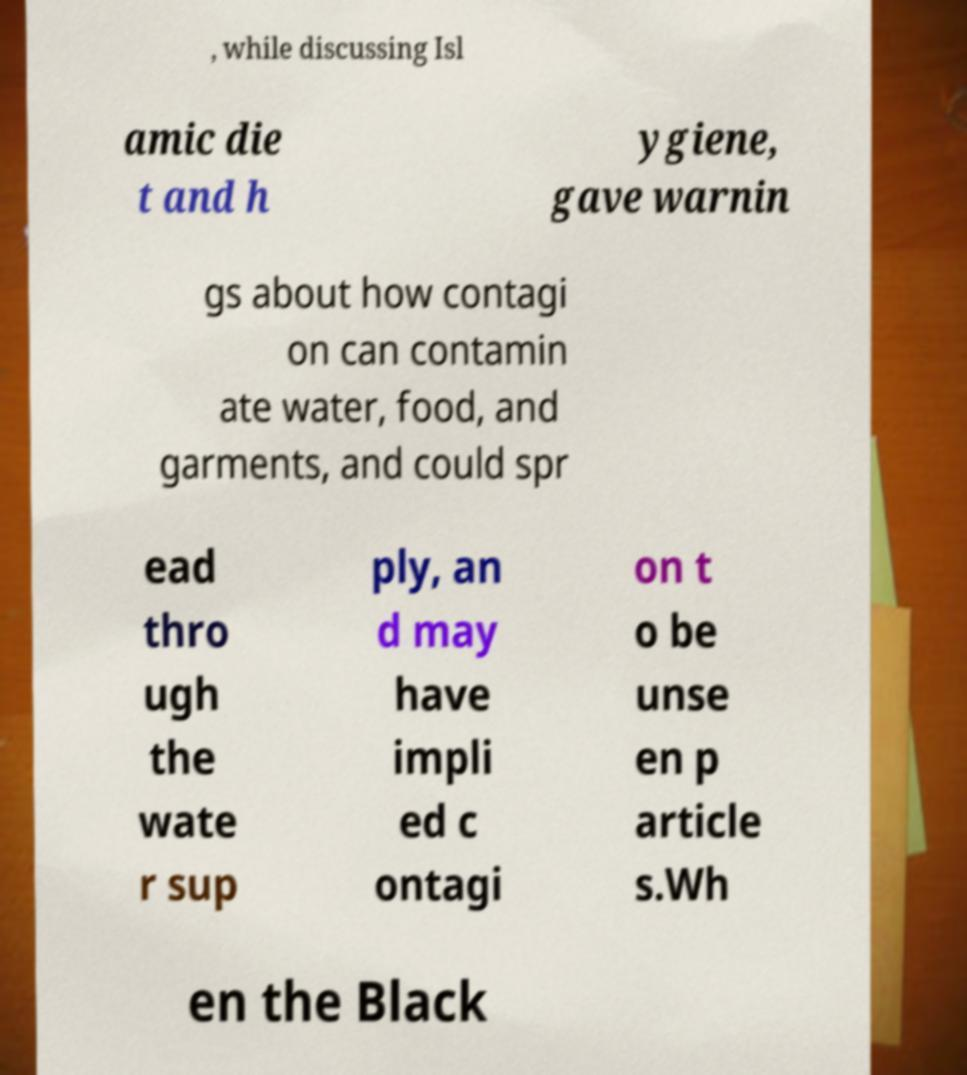There's text embedded in this image that I need extracted. Can you transcribe it verbatim? , while discussing Isl amic die t and h ygiene, gave warnin gs about how contagi on can contamin ate water, food, and garments, and could spr ead thro ugh the wate r sup ply, an d may have impli ed c ontagi on t o be unse en p article s.Wh en the Black 